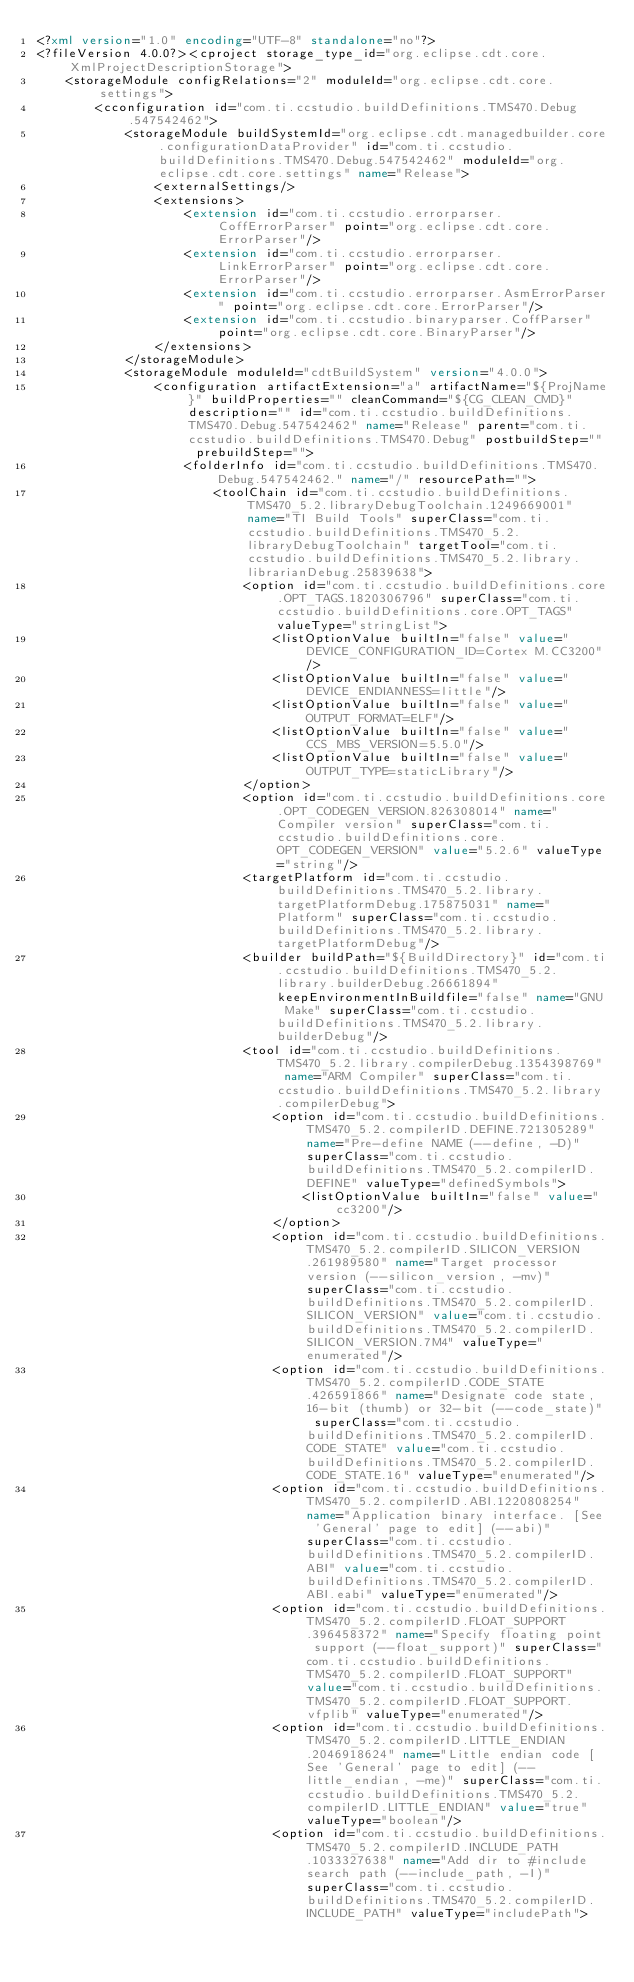<code> <loc_0><loc_0><loc_500><loc_500><_XML_><?xml version="1.0" encoding="UTF-8" standalone="no"?>
<?fileVersion 4.0.0?><cproject storage_type_id="org.eclipse.cdt.core.XmlProjectDescriptionStorage">
	<storageModule configRelations="2" moduleId="org.eclipse.cdt.core.settings">
		<cconfiguration id="com.ti.ccstudio.buildDefinitions.TMS470.Debug.547542462">
			<storageModule buildSystemId="org.eclipse.cdt.managedbuilder.core.configurationDataProvider" id="com.ti.ccstudio.buildDefinitions.TMS470.Debug.547542462" moduleId="org.eclipse.cdt.core.settings" name="Release">
				<externalSettings/>
				<extensions>
					<extension id="com.ti.ccstudio.errorparser.CoffErrorParser" point="org.eclipse.cdt.core.ErrorParser"/>
					<extension id="com.ti.ccstudio.errorparser.LinkErrorParser" point="org.eclipse.cdt.core.ErrorParser"/>
					<extension id="com.ti.ccstudio.errorparser.AsmErrorParser" point="org.eclipse.cdt.core.ErrorParser"/>
					<extension id="com.ti.ccstudio.binaryparser.CoffParser" point="org.eclipse.cdt.core.BinaryParser"/>
				</extensions>
			</storageModule>
			<storageModule moduleId="cdtBuildSystem" version="4.0.0">
				<configuration artifactExtension="a" artifactName="${ProjName}" buildProperties="" cleanCommand="${CG_CLEAN_CMD}" description="" id="com.ti.ccstudio.buildDefinitions.TMS470.Debug.547542462" name="Release" parent="com.ti.ccstudio.buildDefinitions.TMS470.Debug" postbuildStep="" prebuildStep="">
					<folderInfo id="com.ti.ccstudio.buildDefinitions.TMS470.Debug.547542462." name="/" resourcePath="">
						<toolChain id="com.ti.ccstudio.buildDefinitions.TMS470_5.2.libraryDebugToolchain.1249669001" name="TI Build Tools" superClass="com.ti.ccstudio.buildDefinitions.TMS470_5.2.libraryDebugToolchain" targetTool="com.ti.ccstudio.buildDefinitions.TMS470_5.2.library.librarianDebug.25839638">
							<option id="com.ti.ccstudio.buildDefinitions.core.OPT_TAGS.1820306796" superClass="com.ti.ccstudio.buildDefinitions.core.OPT_TAGS" valueType="stringList">
								<listOptionValue builtIn="false" value="DEVICE_CONFIGURATION_ID=Cortex M.CC3200"/>
								<listOptionValue builtIn="false" value="DEVICE_ENDIANNESS=little"/>
								<listOptionValue builtIn="false" value="OUTPUT_FORMAT=ELF"/>
								<listOptionValue builtIn="false" value="CCS_MBS_VERSION=5.5.0"/>
								<listOptionValue builtIn="false" value="OUTPUT_TYPE=staticLibrary"/>
							</option>
							<option id="com.ti.ccstudio.buildDefinitions.core.OPT_CODEGEN_VERSION.826308014" name="Compiler version" superClass="com.ti.ccstudio.buildDefinitions.core.OPT_CODEGEN_VERSION" value="5.2.6" valueType="string"/>
							<targetPlatform id="com.ti.ccstudio.buildDefinitions.TMS470_5.2.library.targetPlatformDebug.175875031" name="Platform" superClass="com.ti.ccstudio.buildDefinitions.TMS470_5.2.library.targetPlatformDebug"/>
							<builder buildPath="${BuildDirectory}" id="com.ti.ccstudio.buildDefinitions.TMS470_5.2.library.builderDebug.26661894" keepEnvironmentInBuildfile="false" name="GNU Make" superClass="com.ti.ccstudio.buildDefinitions.TMS470_5.2.library.builderDebug"/>
							<tool id="com.ti.ccstudio.buildDefinitions.TMS470_5.2.library.compilerDebug.1354398769" name="ARM Compiler" superClass="com.ti.ccstudio.buildDefinitions.TMS470_5.2.library.compilerDebug">
								<option id="com.ti.ccstudio.buildDefinitions.TMS470_5.2.compilerID.DEFINE.721305289" name="Pre-define NAME (--define, -D)" superClass="com.ti.ccstudio.buildDefinitions.TMS470_5.2.compilerID.DEFINE" valueType="definedSymbols">
									<listOptionValue builtIn="false" value="cc3200"/>
								</option>
								<option id="com.ti.ccstudio.buildDefinitions.TMS470_5.2.compilerID.SILICON_VERSION.261989580" name="Target processor version (--silicon_version, -mv)" superClass="com.ti.ccstudio.buildDefinitions.TMS470_5.2.compilerID.SILICON_VERSION" value="com.ti.ccstudio.buildDefinitions.TMS470_5.2.compilerID.SILICON_VERSION.7M4" valueType="enumerated"/>
								<option id="com.ti.ccstudio.buildDefinitions.TMS470_5.2.compilerID.CODE_STATE.426591866" name="Designate code state, 16-bit (thumb) or 32-bit (--code_state)" superClass="com.ti.ccstudio.buildDefinitions.TMS470_5.2.compilerID.CODE_STATE" value="com.ti.ccstudio.buildDefinitions.TMS470_5.2.compilerID.CODE_STATE.16" valueType="enumerated"/>
								<option id="com.ti.ccstudio.buildDefinitions.TMS470_5.2.compilerID.ABI.1220808254" name="Application binary interface. [See 'General' page to edit] (--abi)" superClass="com.ti.ccstudio.buildDefinitions.TMS470_5.2.compilerID.ABI" value="com.ti.ccstudio.buildDefinitions.TMS470_5.2.compilerID.ABI.eabi" valueType="enumerated"/>
								<option id="com.ti.ccstudio.buildDefinitions.TMS470_5.2.compilerID.FLOAT_SUPPORT.396458372" name="Specify floating point support (--float_support)" superClass="com.ti.ccstudio.buildDefinitions.TMS470_5.2.compilerID.FLOAT_SUPPORT" value="com.ti.ccstudio.buildDefinitions.TMS470_5.2.compilerID.FLOAT_SUPPORT.vfplib" valueType="enumerated"/>
								<option id="com.ti.ccstudio.buildDefinitions.TMS470_5.2.compilerID.LITTLE_ENDIAN.2046918624" name="Little endian code [See 'General' page to edit] (--little_endian, -me)" superClass="com.ti.ccstudio.buildDefinitions.TMS470_5.2.compilerID.LITTLE_ENDIAN" value="true" valueType="boolean"/>
								<option id="com.ti.ccstudio.buildDefinitions.TMS470_5.2.compilerID.INCLUDE_PATH.1033327638" name="Add dir to #include search path (--include_path, -I)" superClass="com.ti.ccstudio.buildDefinitions.TMS470_5.2.compilerID.INCLUDE_PATH" valueType="includePath"></code> 